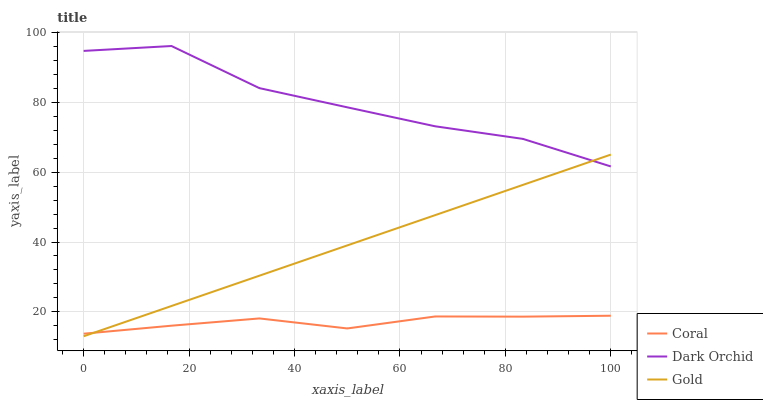Does Coral have the minimum area under the curve?
Answer yes or no. Yes. Does Dark Orchid have the maximum area under the curve?
Answer yes or no. Yes. Does Gold have the minimum area under the curve?
Answer yes or no. No. Does Gold have the maximum area under the curve?
Answer yes or no. No. Is Gold the smoothest?
Answer yes or no. Yes. Is Dark Orchid the roughest?
Answer yes or no. Yes. Is Dark Orchid the smoothest?
Answer yes or no. No. Is Gold the roughest?
Answer yes or no. No. Does Gold have the lowest value?
Answer yes or no. Yes. Does Dark Orchid have the lowest value?
Answer yes or no. No. Does Dark Orchid have the highest value?
Answer yes or no. Yes. Does Gold have the highest value?
Answer yes or no. No. Is Coral less than Dark Orchid?
Answer yes or no. Yes. Is Dark Orchid greater than Coral?
Answer yes or no. Yes. Does Coral intersect Gold?
Answer yes or no. Yes. Is Coral less than Gold?
Answer yes or no. No. Is Coral greater than Gold?
Answer yes or no. No. Does Coral intersect Dark Orchid?
Answer yes or no. No. 